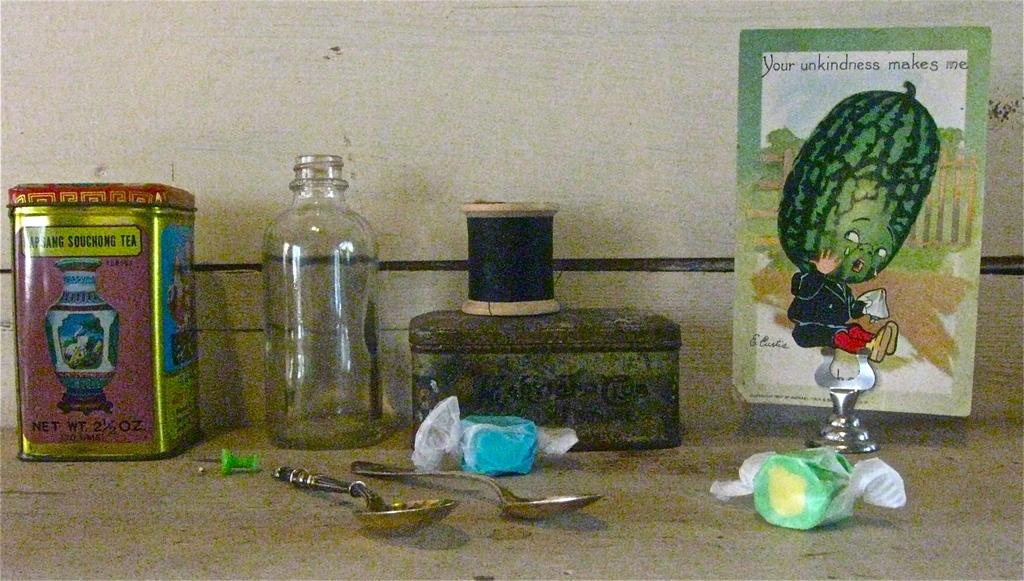What object can be seen in the image that might contain items? There is a box in the image that might contain items. What is another object in the image that might contain a liquid? There is a bottle in the image that might contain a liquid. What type of decoration is present in the image? There is a poster in the image that serves as a decoration. How many utensils are visible in the image? There are two spoons in the image. What type of treat is present in the image? There is a candy in the image. Where is the grandmother sitting in the image? There is no grandmother present in the image. What type of rabbit can be seen hopping in the image? There is no rabbit present in the image. 